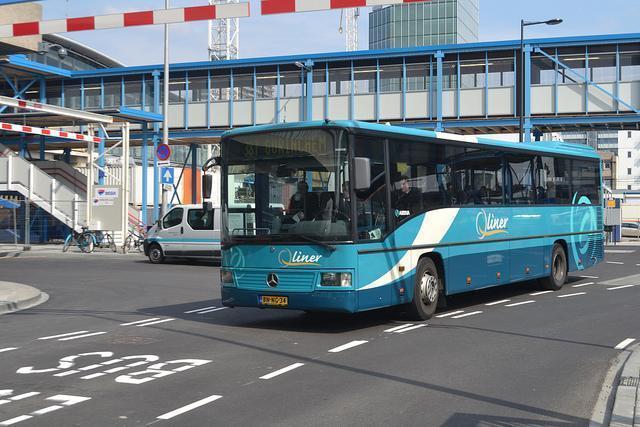What word is on the ground in white letters?
Make your selection from the four choices given to correctly answer the question.
Options: Bus, good, left, car. Bus. 